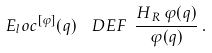<formula> <loc_0><loc_0><loc_500><loc_500>E _ { l } o c ^ { [ \varphi ] } ( q ) \ \ D E F \ \frac { H _ { \, R } \, \varphi ( q ) } { \varphi ( q ) } \, .</formula> 